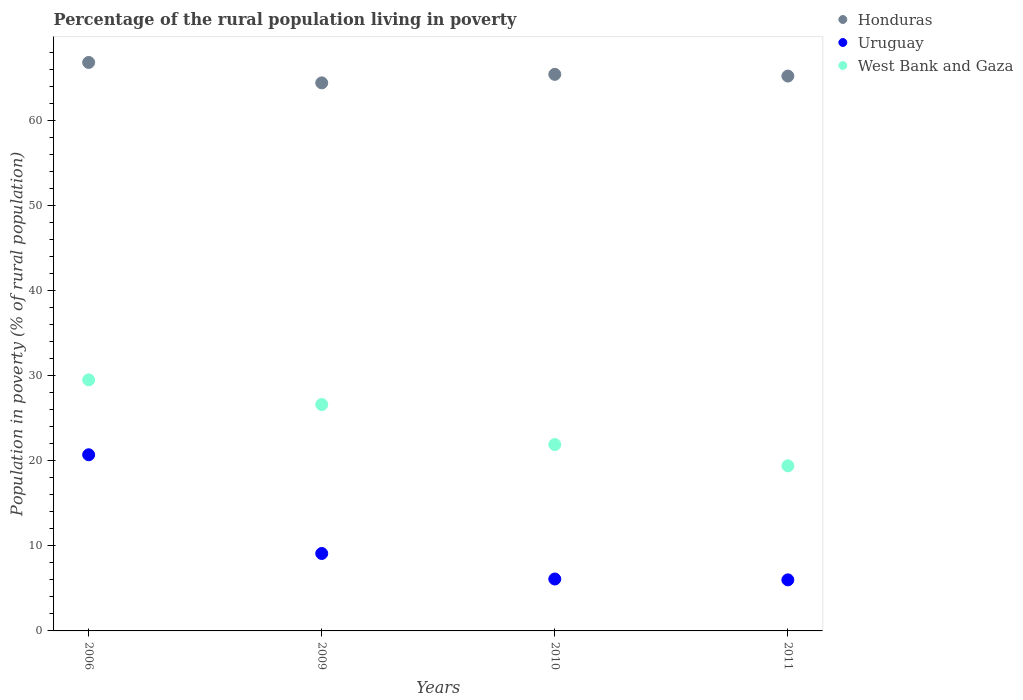How many different coloured dotlines are there?
Your response must be concise. 3. What is the percentage of the rural population living in poverty in Honduras in 2006?
Provide a short and direct response. 66.8. Across all years, what is the maximum percentage of the rural population living in poverty in Honduras?
Offer a terse response. 66.8. Across all years, what is the minimum percentage of the rural population living in poverty in West Bank and Gaza?
Give a very brief answer. 19.4. In which year was the percentage of the rural population living in poverty in Honduras minimum?
Provide a short and direct response. 2009. What is the total percentage of the rural population living in poverty in Honduras in the graph?
Give a very brief answer. 261.8. What is the difference between the percentage of the rural population living in poverty in Honduras in 2006 and that in 2011?
Offer a very short reply. 1.6. What is the difference between the percentage of the rural population living in poverty in Uruguay in 2006 and the percentage of the rural population living in poverty in West Bank and Gaza in 2010?
Make the answer very short. -1.2. What is the average percentage of the rural population living in poverty in Uruguay per year?
Offer a terse response. 10.47. In the year 2006, what is the difference between the percentage of the rural population living in poverty in Honduras and percentage of the rural population living in poverty in Uruguay?
Keep it short and to the point. 46.1. What is the ratio of the percentage of the rural population living in poverty in Honduras in 2009 to that in 2010?
Provide a succinct answer. 0.98. What is the difference between the highest and the second highest percentage of the rural population living in poverty in Honduras?
Ensure brevity in your answer.  1.4. What is the difference between the highest and the lowest percentage of the rural population living in poverty in Honduras?
Offer a very short reply. 2.4. Is it the case that in every year, the sum of the percentage of the rural population living in poverty in West Bank and Gaza and percentage of the rural population living in poverty in Uruguay  is greater than the percentage of the rural population living in poverty in Honduras?
Your answer should be compact. No. Is the percentage of the rural population living in poverty in Uruguay strictly less than the percentage of the rural population living in poverty in West Bank and Gaza over the years?
Provide a succinct answer. Yes. How many dotlines are there?
Your response must be concise. 3. What is the difference between two consecutive major ticks on the Y-axis?
Your answer should be very brief. 10. Does the graph contain grids?
Give a very brief answer. No. What is the title of the graph?
Give a very brief answer. Percentage of the rural population living in poverty. Does "East Asia (all income levels)" appear as one of the legend labels in the graph?
Keep it short and to the point. No. What is the label or title of the Y-axis?
Make the answer very short. Population in poverty (% of rural population). What is the Population in poverty (% of rural population) in Honduras in 2006?
Make the answer very short. 66.8. What is the Population in poverty (% of rural population) of Uruguay in 2006?
Give a very brief answer. 20.7. What is the Population in poverty (% of rural population) of West Bank and Gaza in 2006?
Offer a very short reply. 29.5. What is the Population in poverty (% of rural population) of Honduras in 2009?
Your answer should be very brief. 64.4. What is the Population in poverty (% of rural population) of Uruguay in 2009?
Your response must be concise. 9.1. What is the Population in poverty (% of rural population) in West Bank and Gaza in 2009?
Your response must be concise. 26.6. What is the Population in poverty (% of rural population) of Honduras in 2010?
Ensure brevity in your answer.  65.4. What is the Population in poverty (% of rural population) in West Bank and Gaza in 2010?
Offer a very short reply. 21.9. What is the Population in poverty (% of rural population) of Honduras in 2011?
Provide a short and direct response. 65.2. What is the Population in poverty (% of rural population) in Uruguay in 2011?
Your answer should be very brief. 6. What is the Population in poverty (% of rural population) in West Bank and Gaza in 2011?
Provide a short and direct response. 19.4. Across all years, what is the maximum Population in poverty (% of rural population) in Honduras?
Provide a succinct answer. 66.8. Across all years, what is the maximum Population in poverty (% of rural population) of Uruguay?
Provide a short and direct response. 20.7. Across all years, what is the maximum Population in poverty (% of rural population) in West Bank and Gaza?
Offer a terse response. 29.5. Across all years, what is the minimum Population in poverty (% of rural population) in Honduras?
Your answer should be very brief. 64.4. Across all years, what is the minimum Population in poverty (% of rural population) of West Bank and Gaza?
Keep it short and to the point. 19.4. What is the total Population in poverty (% of rural population) of Honduras in the graph?
Keep it short and to the point. 261.8. What is the total Population in poverty (% of rural population) of Uruguay in the graph?
Your response must be concise. 41.9. What is the total Population in poverty (% of rural population) in West Bank and Gaza in the graph?
Provide a short and direct response. 97.4. What is the difference between the Population in poverty (% of rural population) in Honduras in 2006 and that in 2010?
Offer a very short reply. 1.4. What is the difference between the Population in poverty (% of rural population) in Uruguay in 2006 and that in 2010?
Provide a short and direct response. 14.6. What is the difference between the Population in poverty (% of rural population) in West Bank and Gaza in 2006 and that in 2010?
Provide a short and direct response. 7.6. What is the difference between the Population in poverty (% of rural population) of West Bank and Gaza in 2009 and that in 2011?
Your response must be concise. 7.2. What is the difference between the Population in poverty (% of rural population) of Honduras in 2010 and that in 2011?
Your answer should be compact. 0.2. What is the difference between the Population in poverty (% of rural population) of Uruguay in 2010 and that in 2011?
Make the answer very short. 0.1. What is the difference between the Population in poverty (% of rural population) of West Bank and Gaza in 2010 and that in 2011?
Your answer should be compact. 2.5. What is the difference between the Population in poverty (% of rural population) of Honduras in 2006 and the Population in poverty (% of rural population) of Uruguay in 2009?
Offer a terse response. 57.7. What is the difference between the Population in poverty (% of rural population) in Honduras in 2006 and the Population in poverty (% of rural population) in West Bank and Gaza in 2009?
Provide a short and direct response. 40.2. What is the difference between the Population in poverty (% of rural population) in Uruguay in 2006 and the Population in poverty (% of rural population) in West Bank and Gaza in 2009?
Your response must be concise. -5.9. What is the difference between the Population in poverty (% of rural population) of Honduras in 2006 and the Population in poverty (% of rural population) of Uruguay in 2010?
Give a very brief answer. 60.7. What is the difference between the Population in poverty (% of rural population) in Honduras in 2006 and the Population in poverty (% of rural population) in West Bank and Gaza in 2010?
Make the answer very short. 44.9. What is the difference between the Population in poverty (% of rural population) in Honduras in 2006 and the Population in poverty (% of rural population) in Uruguay in 2011?
Your answer should be very brief. 60.8. What is the difference between the Population in poverty (% of rural population) in Honduras in 2006 and the Population in poverty (% of rural population) in West Bank and Gaza in 2011?
Provide a short and direct response. 47.4. What is the difference between the Population in poverty (% of rural population) in Honduras in 2009 and the Population in poverty (% of rural population) in Uruguay in 2010?
Give a very brief answer. 58.3. What is the difference between the Population in poverty (% of rural population) of Honduras in 2009 and the Population in poverty (% of rural population) of West Bank and Gaza in 2010?
Keep it short and to the point. 42.5. What is the difference between the Population in poverty (% of rural population) of Uruguay in 2009 and the Population in poverty (% of rural population) of West Bank and Gaza in 2010?
Keep it short and to the point. -12.8. What is the difference between the Population in poverty (% of rural population) of Honduras in 2009 and the Population in poverty (% of rural population) of Uruguay in 2011?
Offer a terse response. 58.4. What is the difference between the Population in poverty (% of rural population) of Uruguay in 2009 and the Population in poverty (% of rural population) of West Bank and Gaza in 2011?
Your answer should be very brief. -10.3. What is the difference between the Population in poverty (% of rural population) in Honduras in 2010 and the Population in poverty (% of rural population) in Uruguay in 2011?
Offer a terse response. 59.4. What is the difference between the Population in poverty (% of rural population) of Uruguay in 2010 and the Population in poverty (% of rural population) of West Bank and Gaza in 2011?
Your answer should be very brief. -13.3. What is the average Population in poverty (% of rural population) of Honduras per year?
Your answer should be compact. 65.45. What is the average Population in poverty (% of rural population) of Uruguay per year?
Provide a succinct answer. 10.47. What is the average Population in poverty (% of rural population) in West Bank and Gaza per year?
Give a very brief answer. 24.35. In the year 2006, what is the difference between the Population in poverty (% of rural population) of Honduras and Population in poverty (% of rural population) of Uruguay?
Your response must be concise. 46.1. In the year 2006, what is the difference between the Population in poverty (% of rural population) of Honduras and Population in poverty (% of rural population) of West Bank and Gaza?
Ensure brevity in your answer.  37.3. In the year 2009, what is the difference between the Population in poverty (% of rural population) of Honduras and Population in poverty (% of rural population) of Uruguay?
Offer a very short reply. 55.3. In the year 2009, what is the difference between the Population in poverty (% of rural population) of Honduras and Population in poverty (% of rural population) of West Bank and Gaza?
Provide a short and direct response. 37.8. In the year 2009, what is the difference between the Population in poverty (% of rural population) in Uruguay and Population in poverty (% of rural population) in West Bank and Gaza?
Make the answer very short. -17.5. In the year 2010, what is the difference between the Population in poverty (% of rural population) in Honduras and Population in poverty (% of rural population) in Uruguay?
Your answer should be very brief. 59.3. In the year 2010, what is the difference between the Population in poverty (% of rural population) of Honduras and Population in poverty (% of rural population) of West Bank and Gaza?
Offer a terse response. 43.5. In the year 2010, what is the difference between the Population in poverty (% of rural population) in Uruguay and Population in poverty (% of rural population) in West Bank and Gaza?
Offer a very short reply. -15.8. In the year 2011, what is the difference between the Population in poverty (% of rural population) in Honduras and Population in poverty (% of rural population) in Uruguay?
Your answer should be compact. 59.2. In the year 2011, what is the difference between the Population in poverty (% of rural population) in Honduras and Population in poverty (% of rural population) in West Bank and Gaza?
Provide a short and direct response. 45.8. In the year 2011, what is the difference between the Population in poverty (% of rural population) in Uruguay and Population in poverty (% of rural population) in West Bank and Gaza?
Provide a short and direct response. -13.4. What is the ratio of the Population in poverty (% of rural population) of Honduras in 2006 to that in 2009?
Your response must be concise. 1.04. What is the ratio of the Population in poverty (% of rural population) of Uruguay in 2006 to that in 2009?
Your answer should be compact. 2.27. What is the ratio of the Population in poverty (% of rural population) in West Bank and Gaza in 2006 to that in 2009?
Give a very brief answer. 1.11. What is the ratio of the Population in poverty (% of rural population) of Honduras in 2006 to that in 2010?
Your answer should be very brief. 1.02. What is the ratio of the Population in poverty (% of rural population) of Uruguay in 2006 to that in 2010?
Give a very brief answer. 3.39. What is the ratio of the Population in poverty (% of rural population) in West Bank and Gaza in 2006 to that in 2010?
Offer a terse response. 1.35. What is the ratio of the Population in poverty (% of rural population) in Honduras in 2006 to that in 2011?
Keep it short and to the point. 1.02. What is the ratio of the Population in poverty (% of rural population) in Uruguay in 2006 to that in 2011?
Give a very brief answer. 3.45. What is the ratio of the Population in poverty (% of rural population) of West Bank and Gaza in 2006 to that in 2011?
Provide a succinct answer. 1.52. What is the ratio of the Population in poverty (% of rural population) of Honduras in 2009 to that in 2010?
Ensure brevity in your answer.  0.98. What is the ratio of the Population in poverty (% of rural population) in Uruguay in 2009 to that in 2010?
Offer a terse response. 1.49. What is the ratio of the Population in poverty (% of rural population) in West Bank and Gaza in 2009 to that in 2010?
Your answer should be compact. 1.21. What is the ratio of the Population in poverty (% of rural population) of Honduras in 2009 to that in 2011?
Your answer should be very brief. 0.99. What is the ratio of the Population in poverty (% of rural population) of Uruguay in 2009 to that in 2011?
Provide a short and direct response. 1.52. What is the ratio of the Population in poverty (% of rural population) of West Bank and Gaza in 2009 to that in 2011?
Provide a succinct answer. 1.37. What is the ratio of the Population in poverty (% of rural population) of Uruguay in 2010 to that in 2011?
Provide a short and direct response. 1.02. What is the ratio of the Population in poverty (% of rural population) in West Bank and Gaza in 2010 to that in 2011?
Offer a very short reply. 1.13. What is the difference between the highest and the second highest Population in poverty (% of rural population) of Uruguay?
Provide a succinct answer. 11.6. 